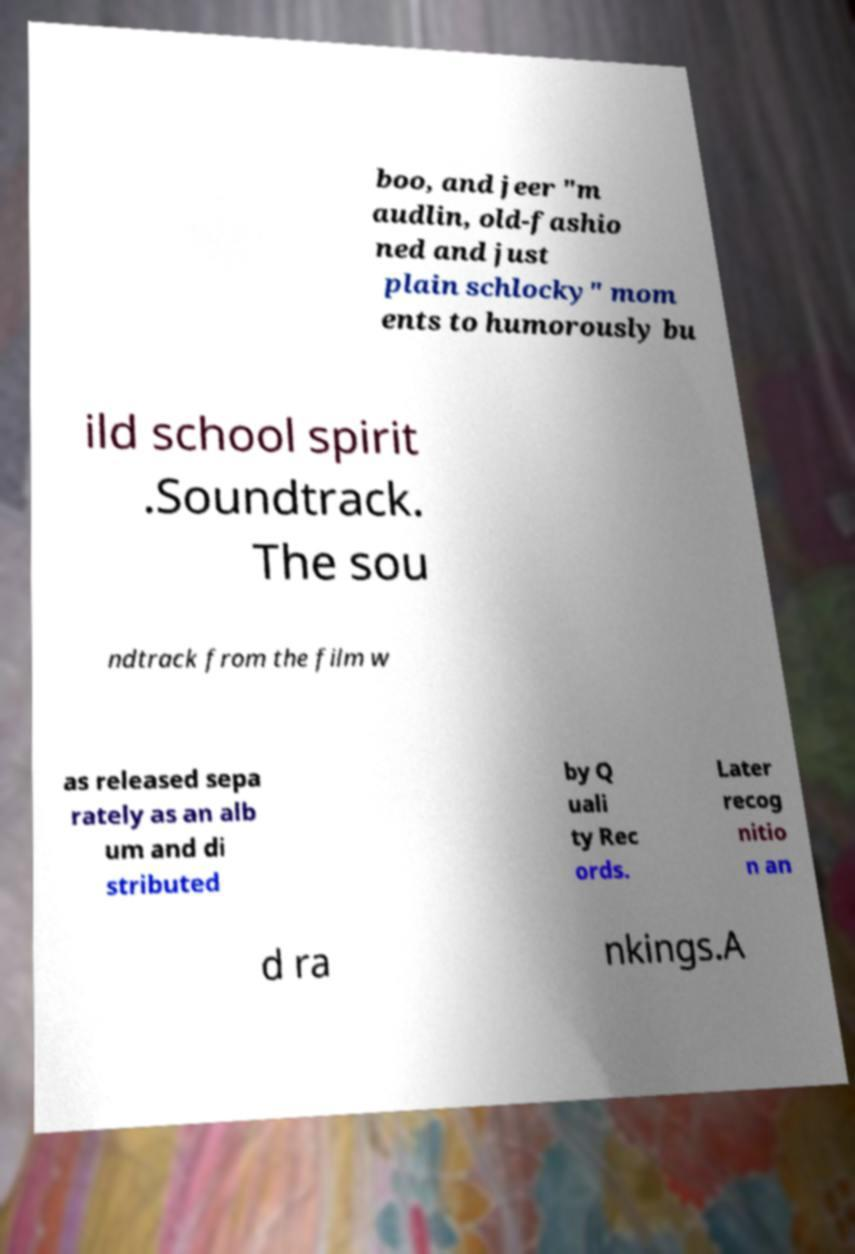Could you extract and type out the text from this image? boo, and jeer "m audlin, old-fashio ned and just plain schlocky" mom ents to humorously bu ild school spirit .Soundtrack. The sou ndtrack from the film w as released sepa rately as an alb um and di stributed by Q uali ty Rec ords. Later recog nitio n an d ra nkings.A 